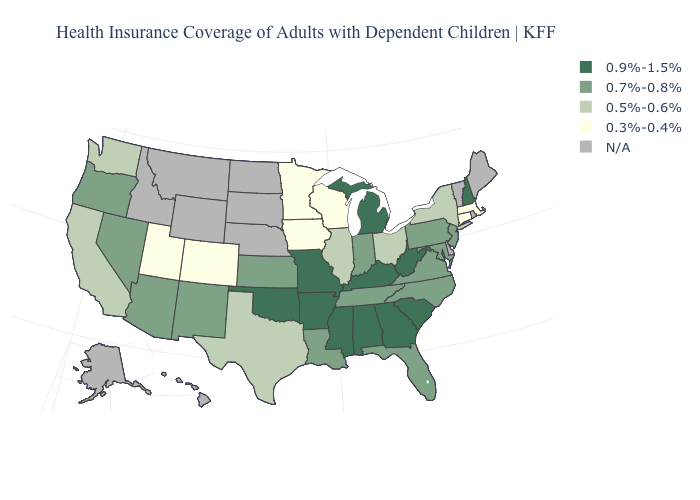Name the states that have a value in the range 0.3%-0.4%?
Give a very brief answer. Colorado, Connecticut, Iowa, Massachusetts, Minnesota, Utah, Wisconsin. Name the states that have a value in the range N/A?
Keep it brief. Alaska, Delaware, Hawaii, Idaho, Maine, Montana, Nebraska, North Dakota, Rhode Island, South Dakota, Vermont, Wyoming. Name the states that have a value in the range 0.9%-1.5%?
Concise answer only. Alabama, Arkansas, Georgia, Kentucky, Michigan, Mississippi, Missouri, New Hampshire, Oklahoma, South Carolina, West Virginia. What is the value of Montana?
Quick response, please. N/A. What is the value of Wyoming?
Give a very brief answer. N/A. Does South Carolina have the highest value in the South?
Keep it brief. Yes. Among the states that border Indiana , does Kentucky have the lowest value?
Give a very brief answer. No. What is the highest value in the West ?
Short answer required. 0.7%-0.8%. What is the lowest value in the MidWest?
Quick response, please. 0.3%-0.4%. Among the states that border Michigan , does Indiana have the highest value?
Write a very short answer. Yes. What is the highest value in states that border Washington?
Concise answer only. 0.7%-0.8%. Among the states that border Pennsylvania , does Ohio have the highest value?
Answer briefly. No. What is the lowest value in the USA?
Concise answer only. 0.3%-0.4%. Does New Hampshire have the lowest value in the Northeast?
Concise answer only. No. Which states have the lowest value in the Northeast?
Quick response, please. Connecticut, Massachusetts. 